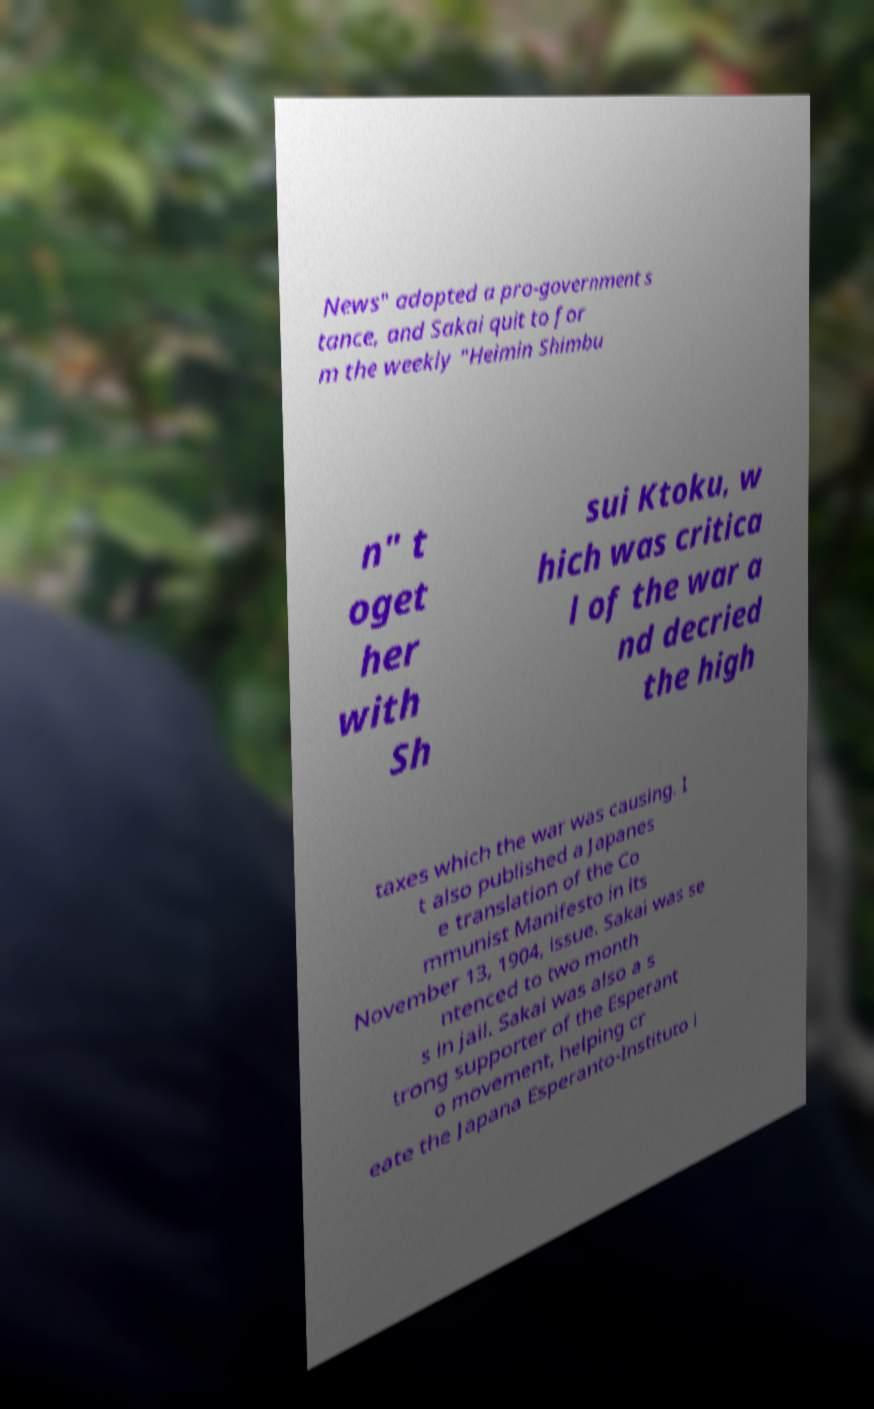Can you read and provide the text displayed in the image?This photo seems to have some interesting text. Can you extract and type it out for me? News" adopted a pro-government s tance, and Sakai quit to for m the weekly "Heimin Shimbu n" t oget her with Sh sui Ktoku, w hich was critica l of the war a nd decried the high taxes which the war was causing. I t also published a Japanes e translation of the Co mmunist Manifesto in its November 13, 1904, issue. Sakai was se ntenced to two month s in jail. Sakai was also a s trong supporter of the Esperant o movement, helping cr eate the Japana Esperanto-Instituto i 